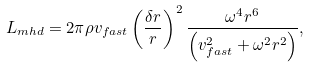Convert formula to latex. <formula><loc_0><loc_0><loc_500><loc_500>L _ { m h d } = 2 \pi \rho v _ { f a s t } \left ( \frac { \delta r } { r } \right ) ^ { 2 } \frac { \omega ^ { 4 } r ^ { 6 } } { \left ( v _ { f a s t } ^ { 2 } + \omega ^ { 2 } r ^ { 2 } \right ) } ,</formula> 